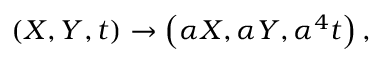<formula> <loc_0><loc_0><loc_500><loc_500>\left ( X , Y , t \right ) \rightarrow \left ( \alpha X , \alpha Y , \alpha ^ { 4 } t \right ) ,</formula> 